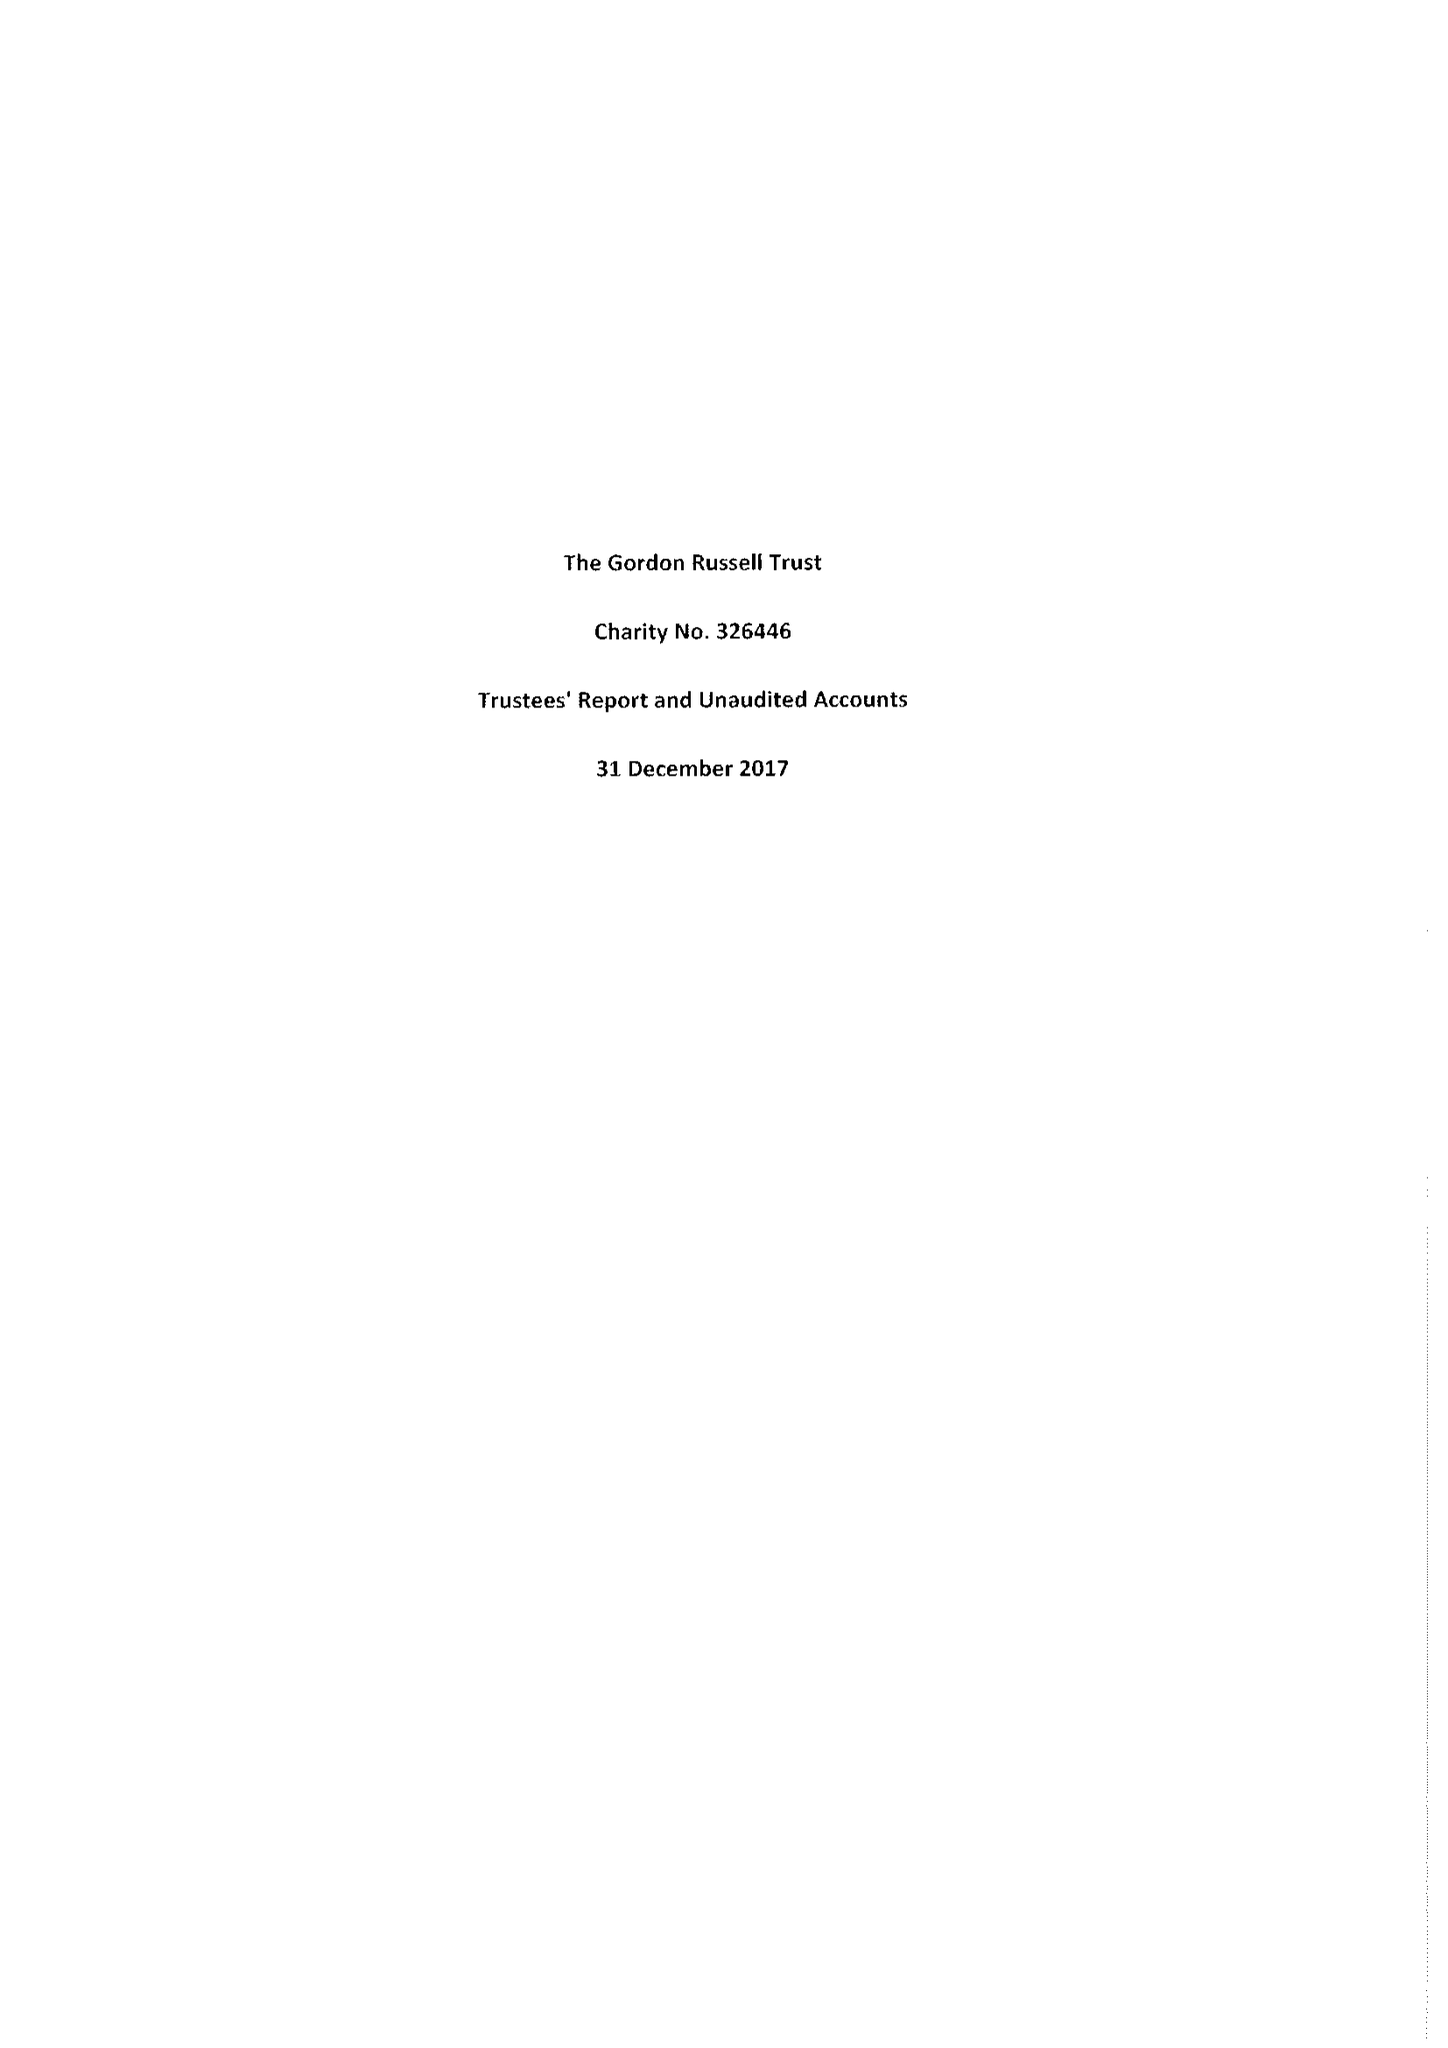What is the value for the charity_number?
Answer the question using a single word or phrase. 326446 